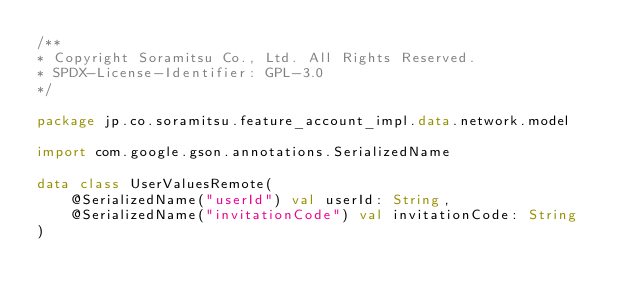<code> <loc_0><loc_0><loc_500><loc_500><_Kotlin_>/**
* Copyright Soramitsu Co., Ltd. All Rights Reserved.
* SPDX-License-Identifier: GPL-3.0
*/

package jp.co.soramitsu.feature_account_impl.data.network.model

import com.google.gson.annotations.SerializedName

data class UserValuesRemote(
    @SerializedName("userId") val userId: String,
    @SerializedName("invitationCode") val invitationCode: String
)</code> 